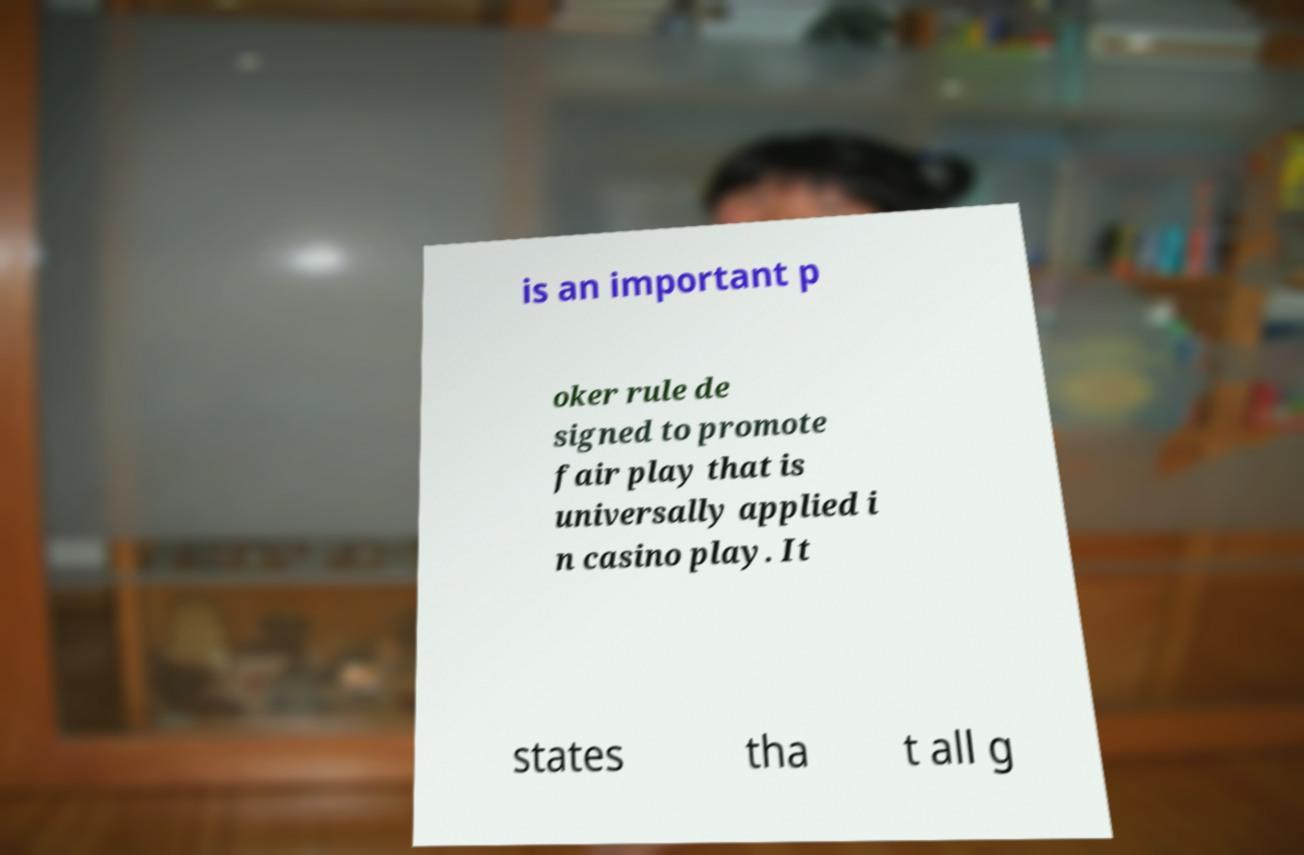For documentation purposes, I need the text within this image transcribed. Could you provide that? is an important p oker rule de signed to promote fair play that is universally applied i n casino play. It states tha t all g 